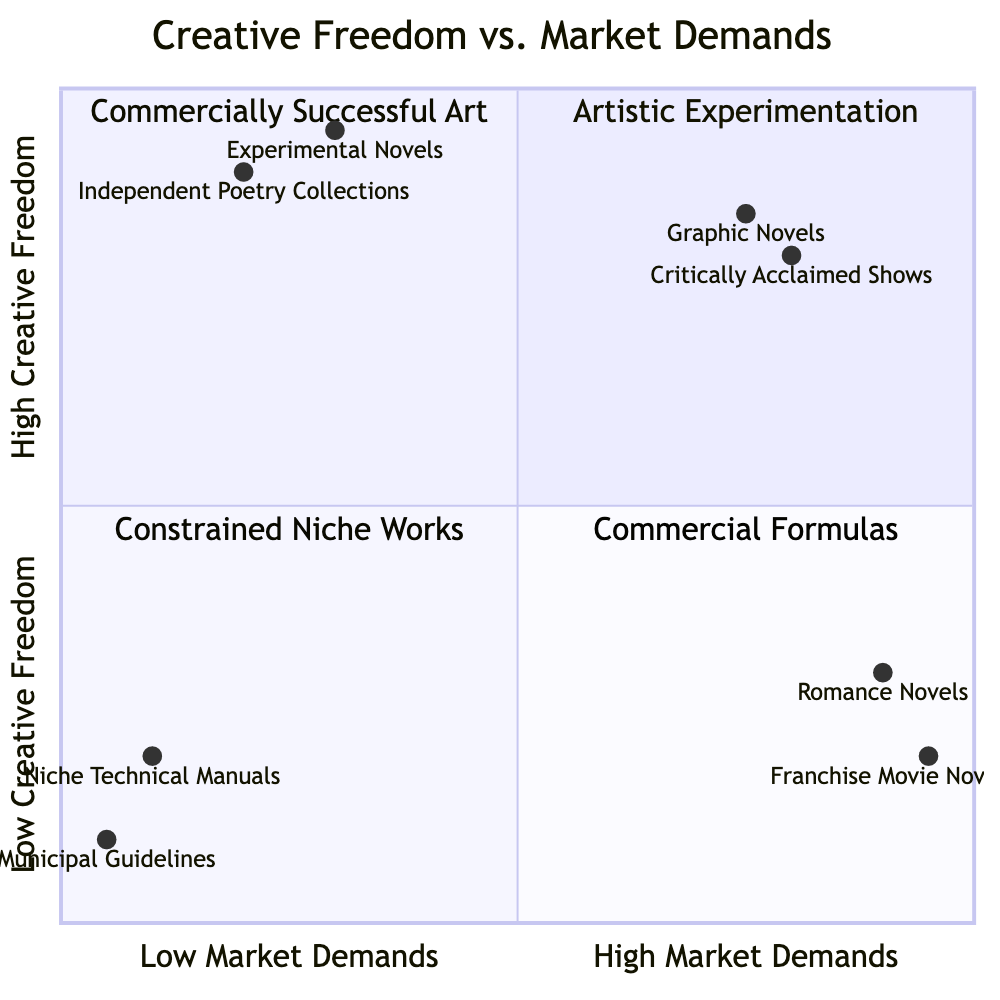What is the highest entity in terms of market demands? In the diagram, the position of entities on the x-axis indicates their level of market demand. The entity furthest to the right (indicating high market demands) is "Franchise Movie Novelizations" at a coordinate of [0.95, 0.2]. Thus, it has the highest market demand among all listed entities.
Answer: Franchise Movie Novelizations Which quadrant contains "Romance Novels from Major Publishers"? "Romance Novels from Major Publishers" is located in Quadrant 4, as it has a low creative freedom score (0.3) paired with high market demands (0.9). This places it squarely in the quadrant defined by low creative freedom and high market demands.
Answer: Quadrant 4 How many examples are in Quadrant 1? Quadrant 1 contains two listed examples: "Independent Poetry Collections" and "Experimental Novels." Therefore, a simple counting of the provided examples leads to the conclusion that there are two.
Answer: 2 What is the creative freedom score of "Graphic Novels"? "Graphic Novels" has a creative freedom score indicated by the y-coordinate of its placement in the diagram, which is 0.85. This number reflects a relatively high level of creative freedom compared to other entities.
Answer: 0.85 Which entity has the lowest market demand? Looking at the x-axis of the diagram, "Municipal Guidelines" has the lowest market demand, as it has a score of 0.05, indicating it serves a very limited audience in terms of market demand.
Answer: Municipal Guidelines What type of works are located in Quadrant 3? Quadrant 3, with its characteristics of low creative freedom and low market demands, includes "Niche Technical Manuals" and "Municipal Guidelines." Thus, these types of works are limited in both creativity and audience engagement.
Answer: Niche Technical Manuals, Municipal Guidelines Which quadrant incorporates both high creative freedom and high market demands? Quadrant 2 is defined by high creative freedom and high market demands, and examples such as "Critically Acclaimed Shows on Streaming Services" and "Graphic Novels" reside in this quadrant. Therefore, Quadrant 2 is the correct descriptor for such a combination of attributes.
Answer: Quadrant 2 What is the coordinate position of "Experimental Novels"? The coordinate position of "Experimental Novels" is provided in the data as [0.3, 0.95], where 0.3 reflects its market demand and 0.95 indicates its high creative freedom. This specific coordinate captures its relative placement in the diagram.
Answer: [0.3, 0.95] 